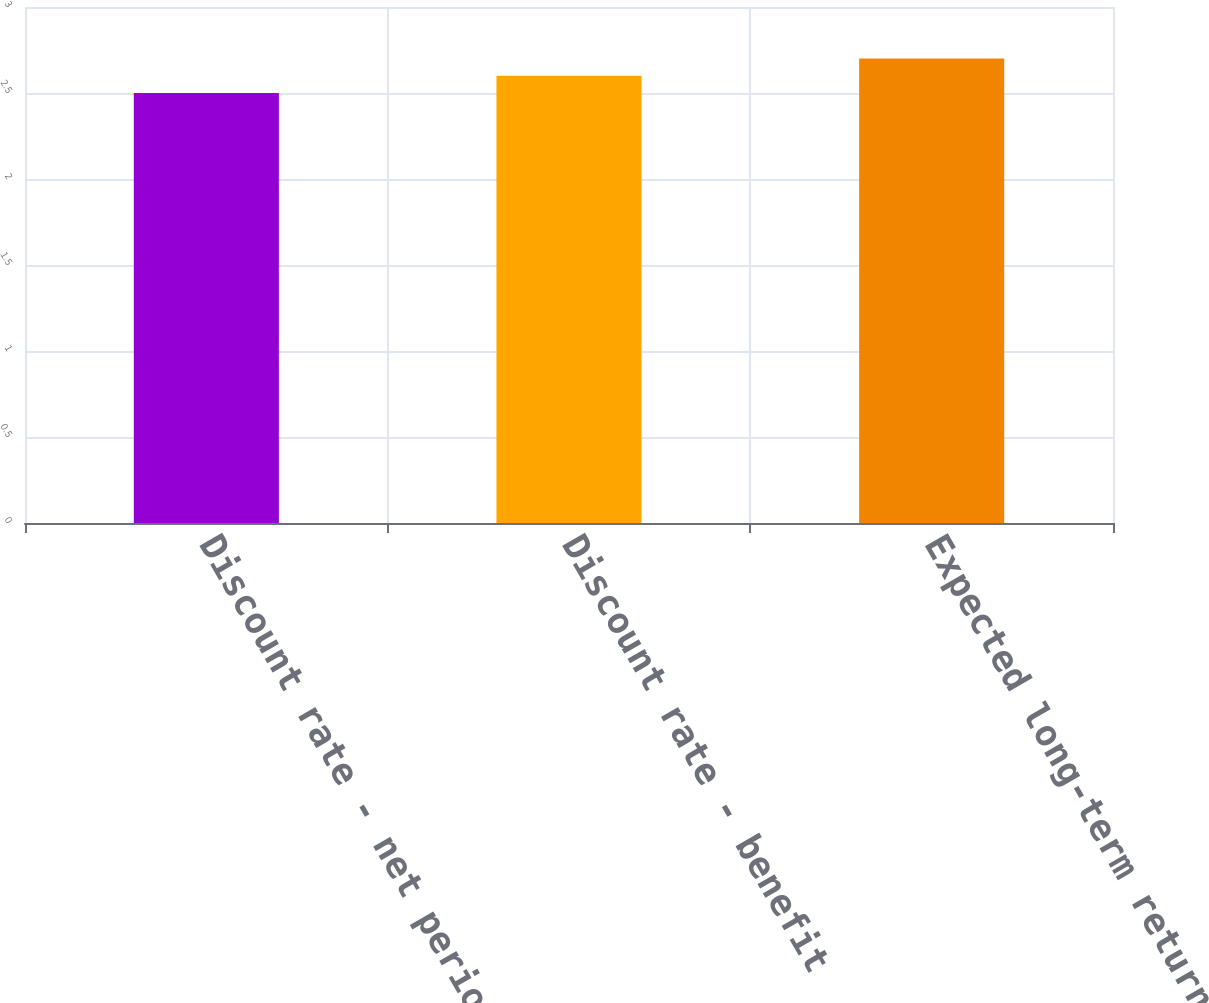<chart> <loc_0><loc_0><loc_500><loc_500><bar_chart><fcel>Discount rate - net periodic<fcel>Discount rate - benefit<fcel>Expected long-term return on<nl><fcel>2.5<fcel>2.6<fcel>2.7<nl></chart> 